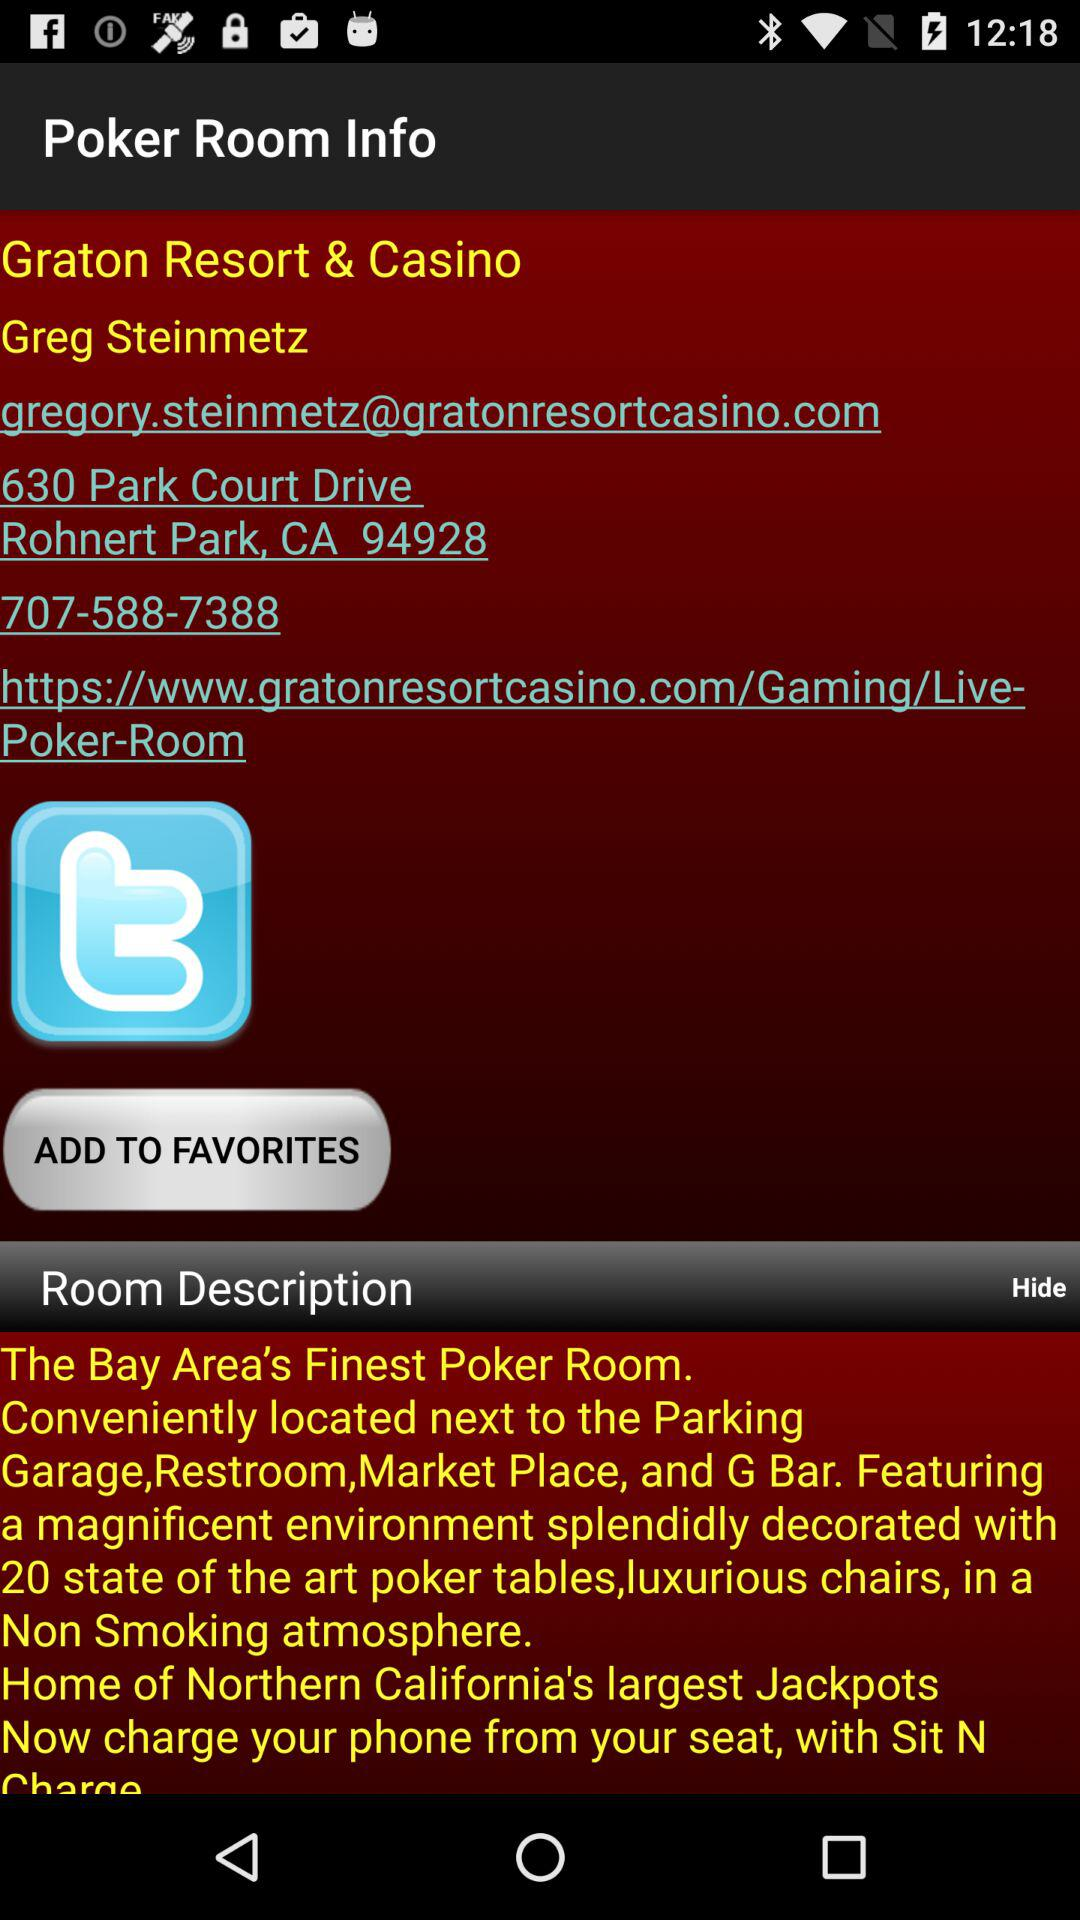Who is the poker manager at "Graton Resort & Casino"? The poker manager is Greg Steinmetz. 